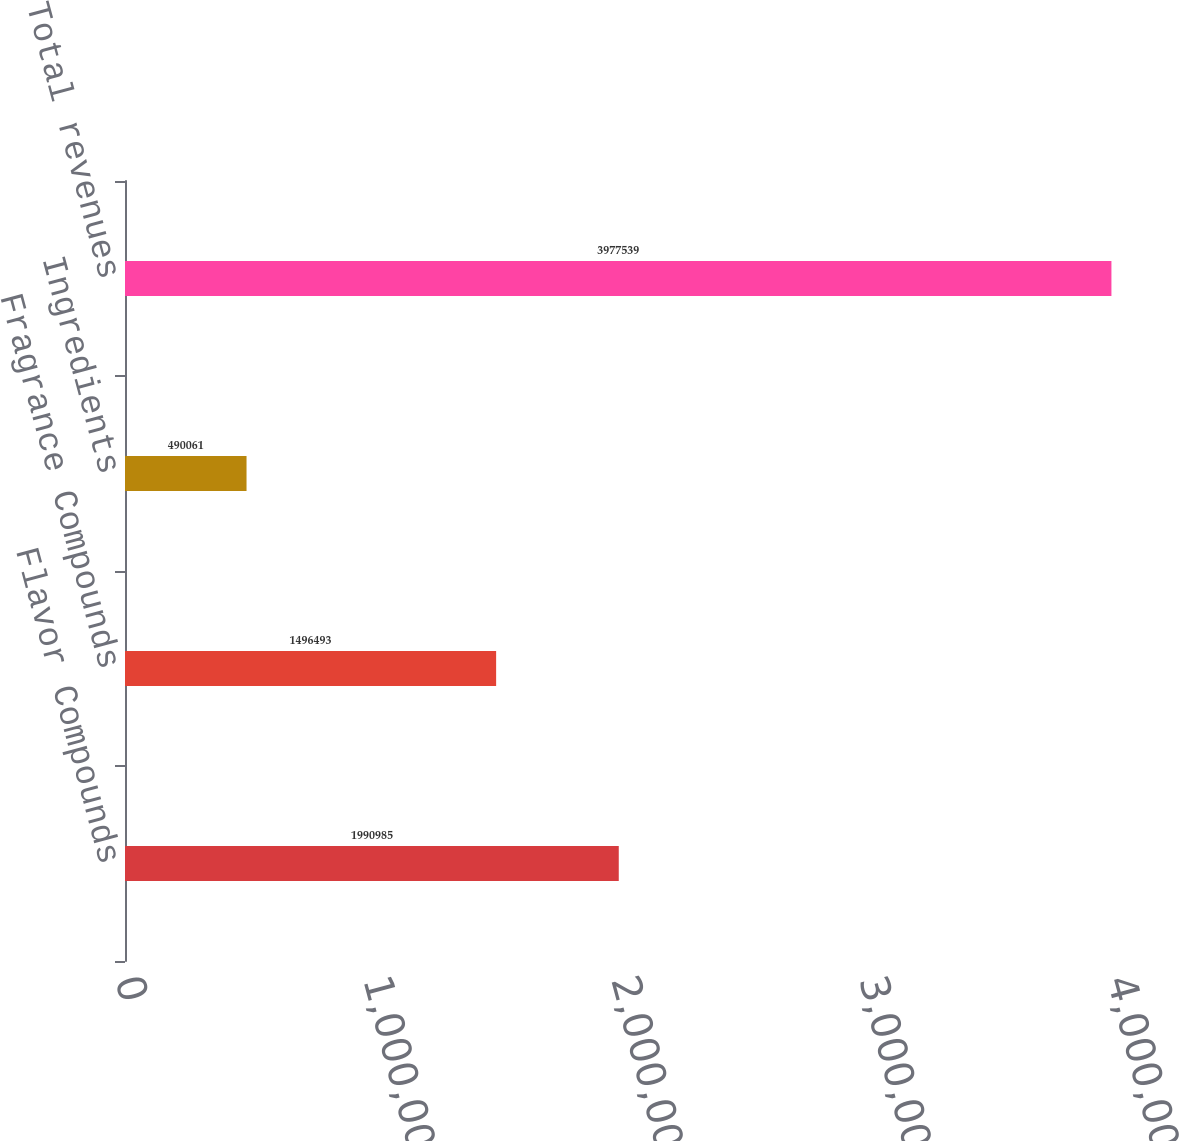Convert chart. <chart><loc_0><loc_0><loc_500><loc_500><bar_chart><fcel>Flavor Compounds<fcel>Fragrance Compounds<fcel>Ingredients<fcel>Total revenues<nl><fcel>1.99098e+06<fcel>1.49649e+06<fcel>490061<fcel>3.97754e+06<nl></chart> 